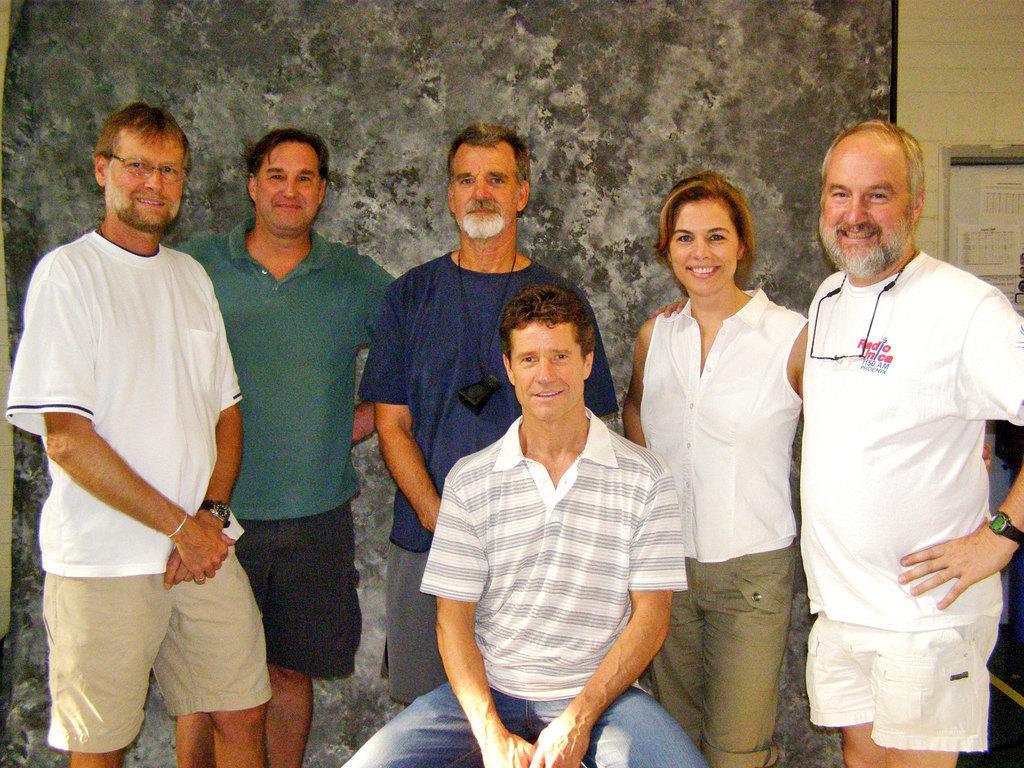Could you give a brief overview of what you see in this image? In this picture we can see a group of people standing and a person is sitting on an object. Behind the people there is a wall. 